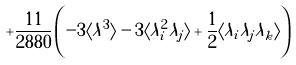<formula> <loc_0><loc_0><loc_500><loc_500>+ \frac { 1 1 } { 2 8 8 0 } \left ( - 3 \langle \lambda ^ { 3 } \rangle - 3 \langle \lambda _ { i } ^ { 2 } \lambda _ { j } \rangle + \frac { 1 } { 2 } \langle \lambda _ { i } \lambda _ { j } \lambda _ { k } \rangle \right )</formula> 